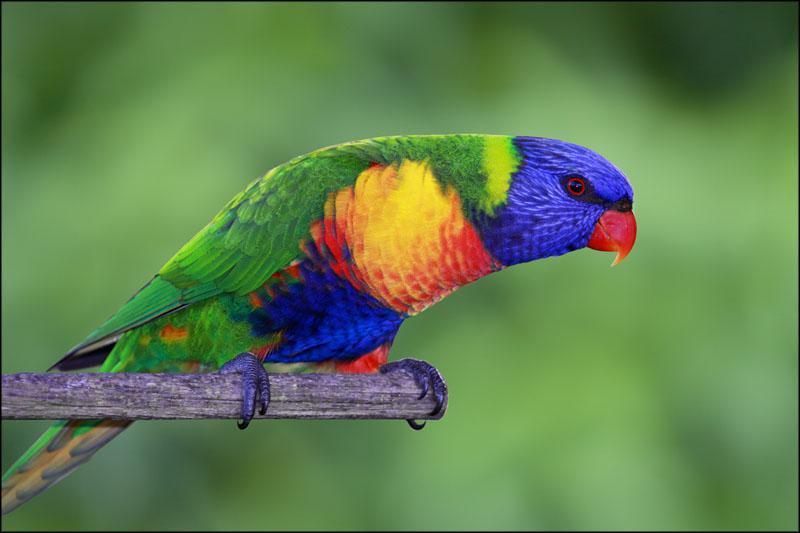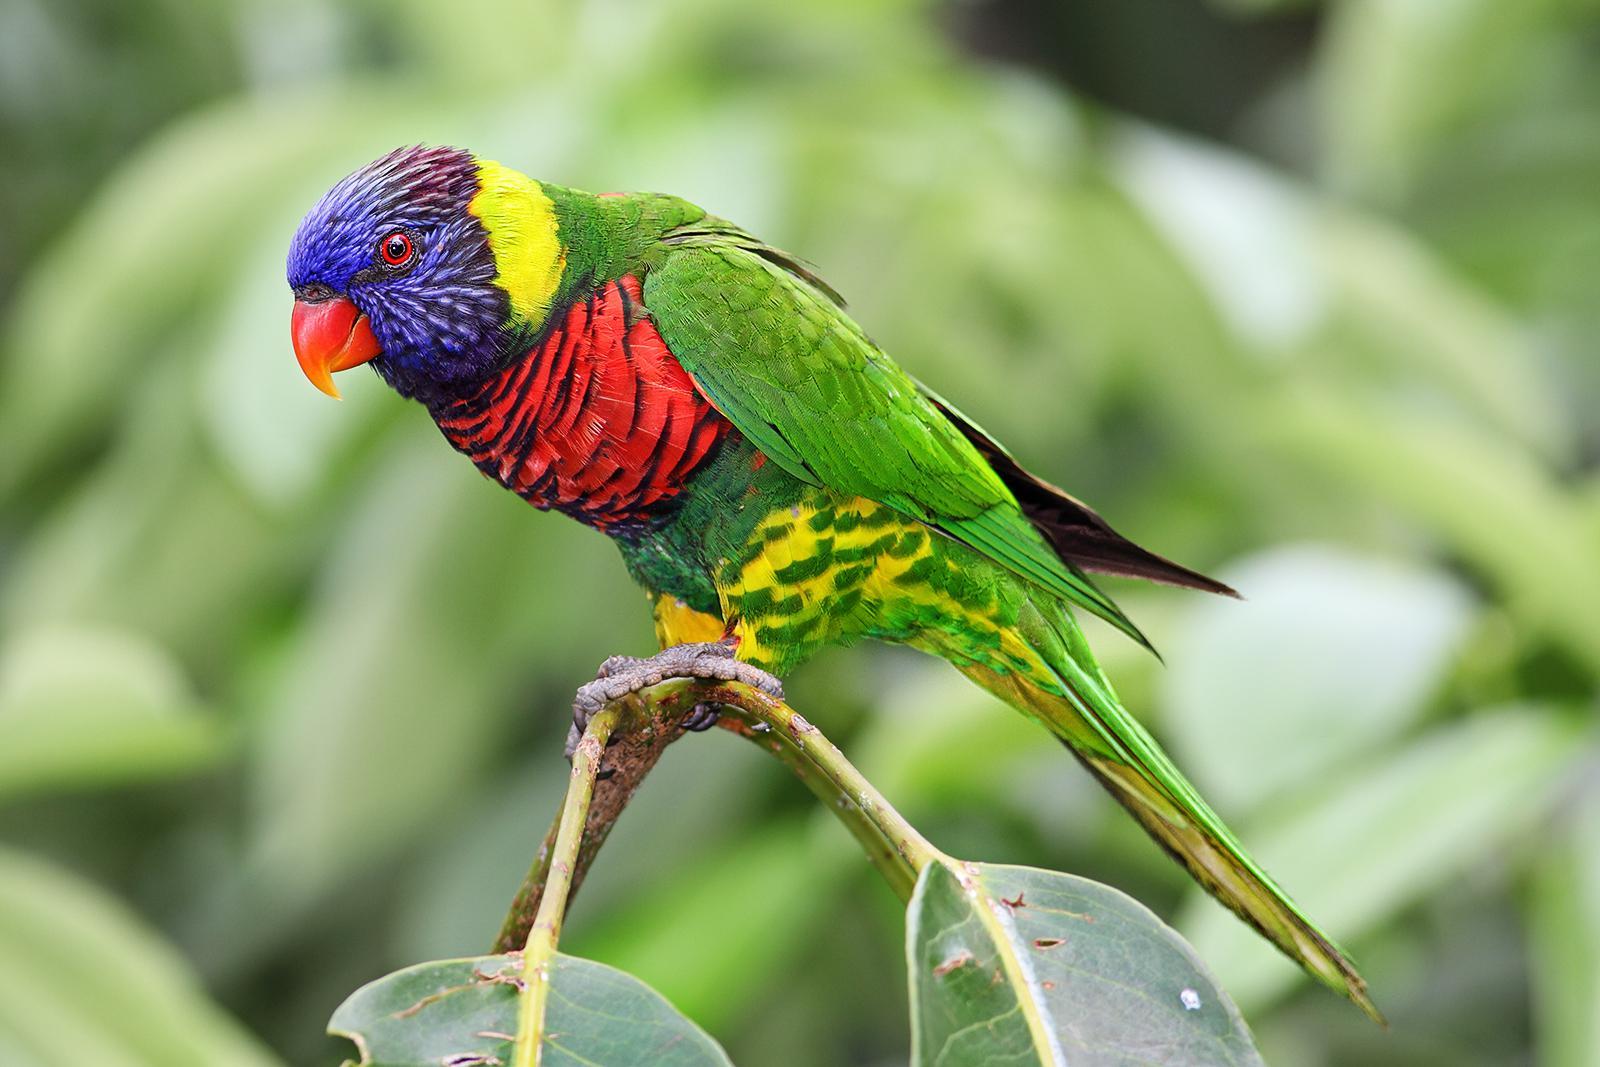The first image is the image on the left, the second image is the image on the right. Assess this claim about the two images: "All of the birds are perched with their breast turned toward the camera.". Correct or not? Answer yes or no. No. 